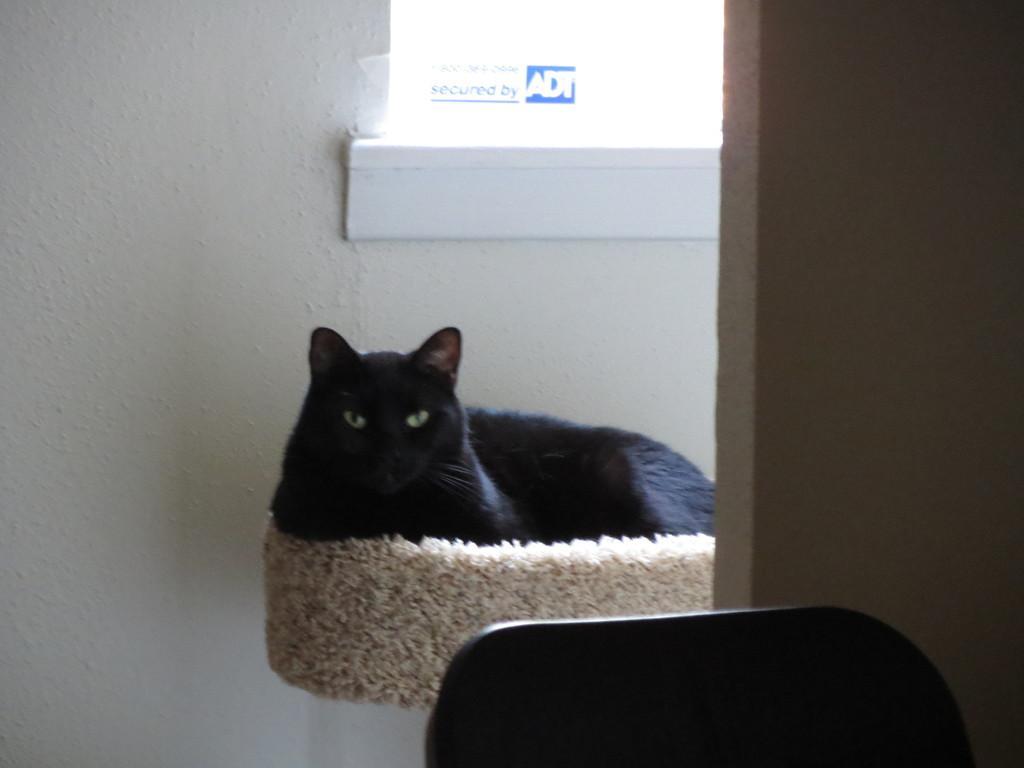Could you give a brief overview of what you see in this image? In this image I can see a cat. There are walls and at the bottom of the image it looks like a chair. 